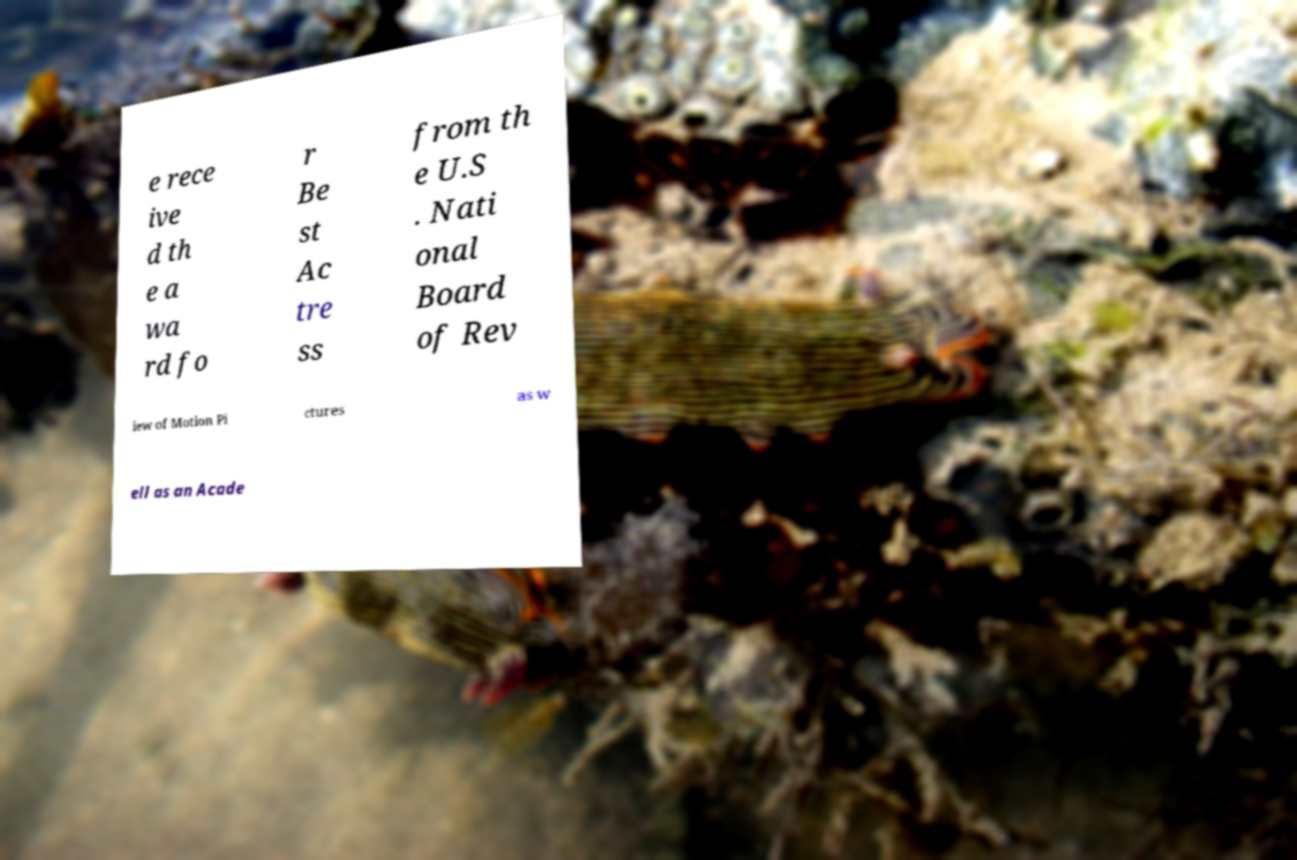Could you extract and type out the text from this image? e rece ive d th e a wa rd fo r Be st Ac tre ss from th e U.S . Nati onal Board of Rev iew of Motion Pi ctures as w ell as an Acade 